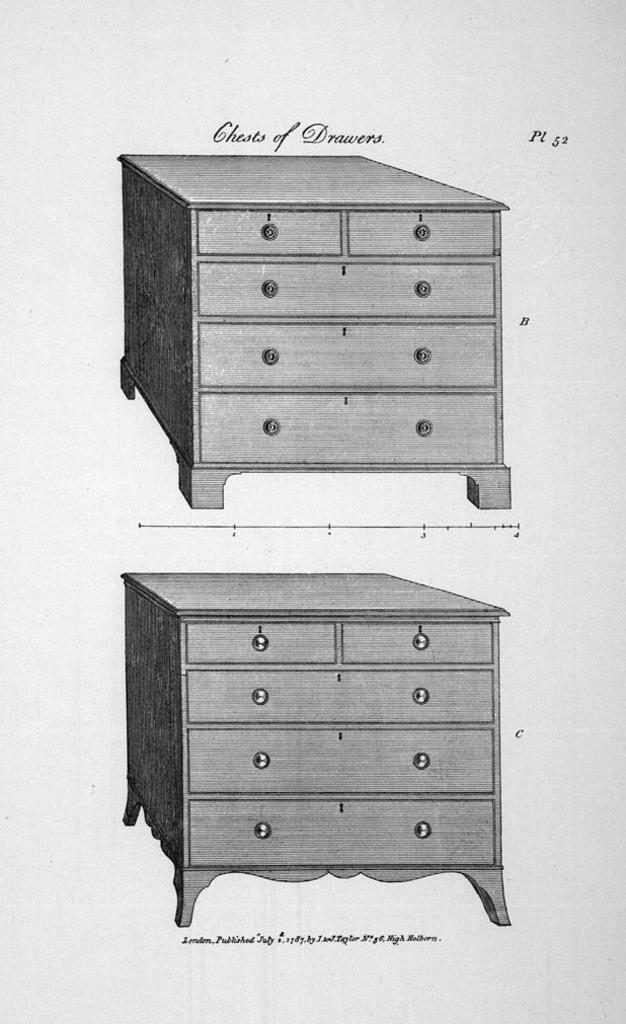What is the color scheme of the image? The image is black and white. What type of objects are depicted in the image? There are two printed images of cupboards in the image. Are there any words or letters on the image? Yes, there is text on the image. Which direction is the volcano erupting in the image? There is no volcano present in the image. What type of toy can be seen playing with the cupboards in the image? There is no toy present in the image. 